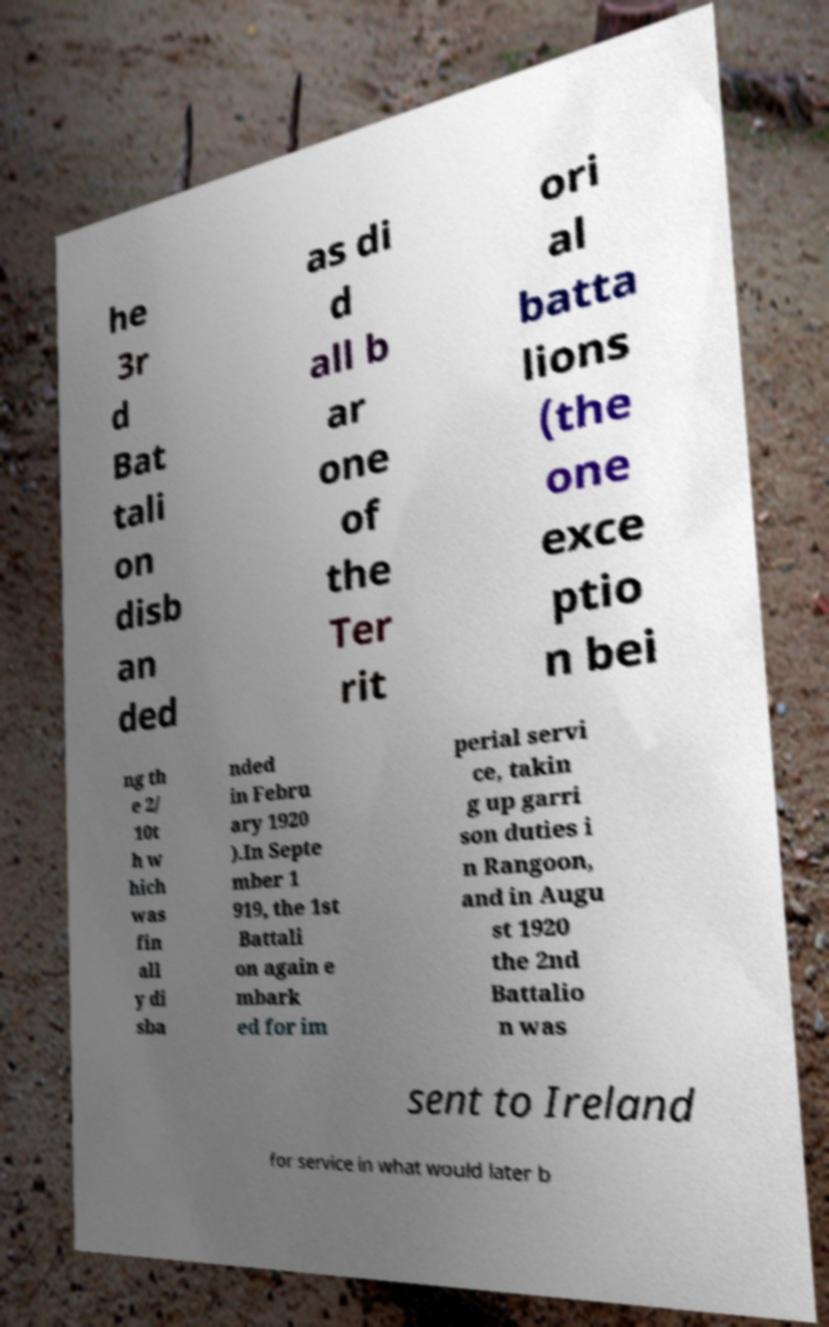Can you accurately transcribe the text from the provided image for me? he 3r d Bat tali on disb an ded as di d all b ar one of the Ter rit ori al batta lions (the one exce ptio n bei ng th e 2/ 10t h w hich was fin all y di sba nded in Febru ary 1920 ).In Septe mber 1 919, the 1st Battali on again e mbark ed for im perial servi ce, takin g up garri son duties i n Rangoon, and in Augu st 1920 the 2nd Battalio n was sent to Ireland for service in what would later b 